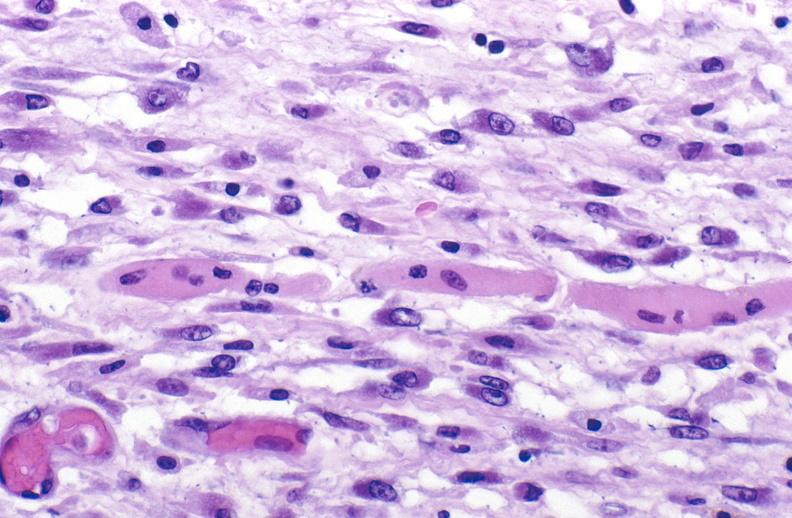what is present?
Answer the question using a single word or phrase. Muscle 